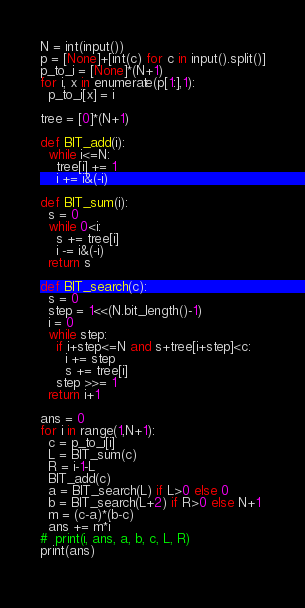<code> <loc_0><loc_0><loc_500><loc_500><_Python_>N = int(input())
p = [None]+[int(c) for c in input().split()]
p_to_i = [None]*(N+1)
for i, x in enumerate(p[1:],1):
  p_to_i[x] = i

tree = [0]*(N+1)

def BIT_add(i):
  while i<=N:
    tree[i] += 1
    i += i&(-i)
    
def BIT_sum(i):
  s = 0
  while 0<i:
    s += tree[i]
    i -= i&(-i)
  return s

def BIT_search(c):
  s = 0
  step = 1<<(N.bit_length()-1)
  i = 0
  while step:
    if i+step<=N and s+tree[i+step]<c:
      i += step
      s += tree[i]
    step >>= 1
  return i+1

ans = 0
for i in range(1,N+1):
  c = p_to_i[i]
  L = BIT_sum(c)
  R = i-1-L
  BIT_add(c)
  a = BIT_search(L) if L>0 else 0
  b = BIT_search(L+2) if R>0 else N+1
  m = (c-a)*(b-c)
  ans += m*i
#  print(i, ans, a, b, c, L, R)
print(ans)
  </code> 